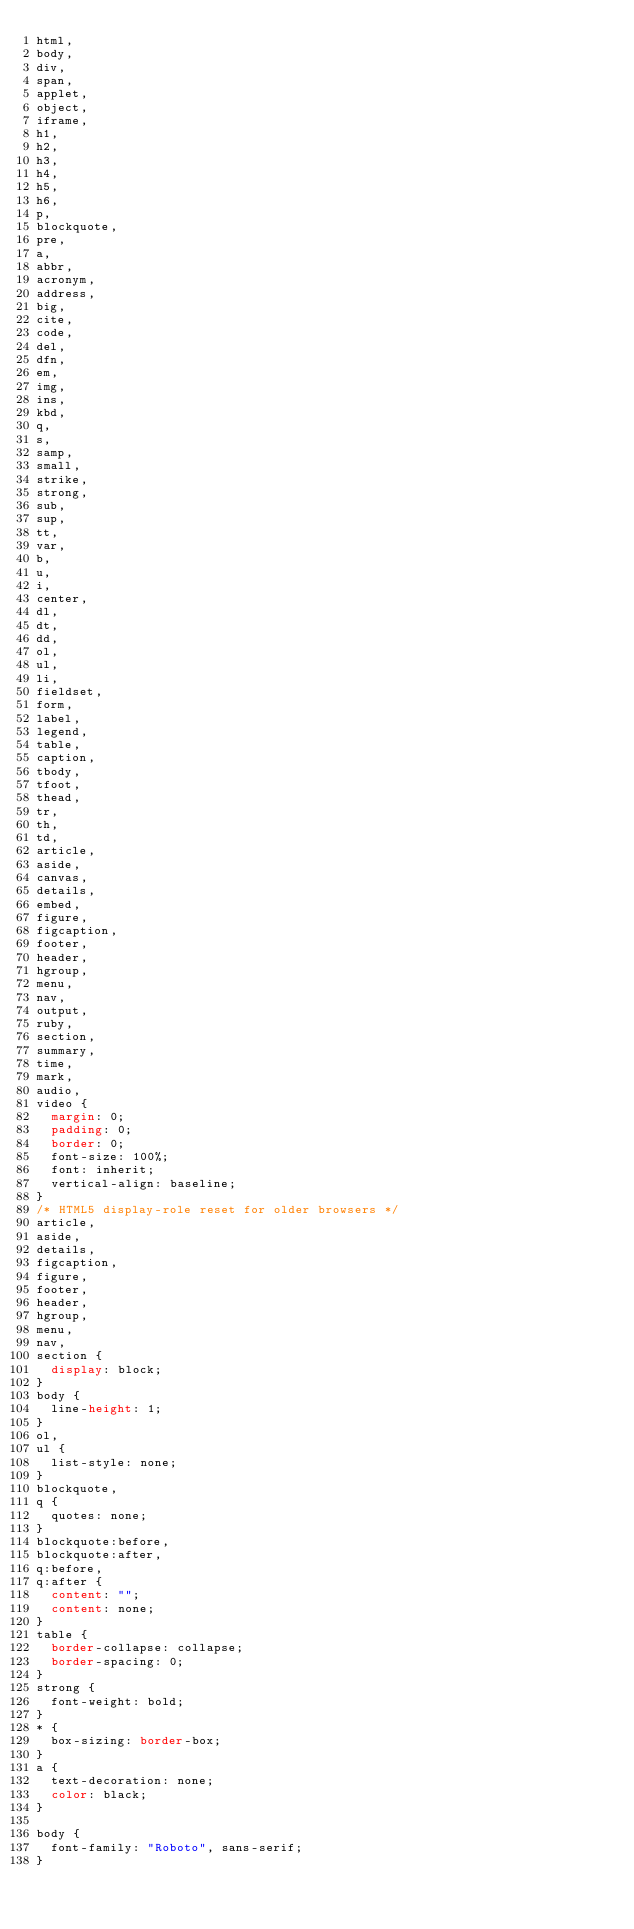Convert code to text. <code><loc_0><loc_0><loc_500><loc_500><_CSS_>html,
body,
div,
span,
applet,
object,
iframe,
h1,
h2,
h3,
h4,
h5,
h6,
p,
blockquote,
pre,
a,
abbr,
acronym,
address,
big,
cite,
code,
del,
dfn,
em,
img,
ins,
kbd,
q,
s,
samp,
small,
strike,
strong,
sub,
sup,
tt,
var,
b,
u,
i,
center,
dl,
dt,
dd,
ol,
ul,
li,
fieldset,
form,
label,
legend,
table,
caption,
tbody,
tfoot,
thead,
tr,
th,
td,
article,
aside,
canvas,
details,
embed,
figure,
figcaption,
footer,
header,
hgroup,
menu,
nav,
output,
ruby,
section,
summary,
time,
mark,
audio,
video {
  margin: 0;
  padding: 0;
  border: 0;
  font-size: 100%;
  font: inherit;
  vertical-align: baseline;
}
/* HTML5 display-role reset for older browsers */
article,
aside,
details,
figcaption,
figure,
footer,
header,
hgroup,
menu,
nav,
section {
  display: block;
}
body {
  line-height: 1;
}
ol,
ul {
  list-style: none;
}
blockquote,
q {
  quotes: none;
}
blockquote:before,
blockquote:after,
q:before,
q:after {
  content: "";
  content: none;
}
table {
  border-collapse: collapse;
  border-spacing: 0;
}
strong {
  font-weight: bold;
}
* {
  box-sizing: border-box;
}
a {
  text-decoration: none;
  color: black;
}

body {
  font-family: "Roboto", sans-serif;
}
</code> 